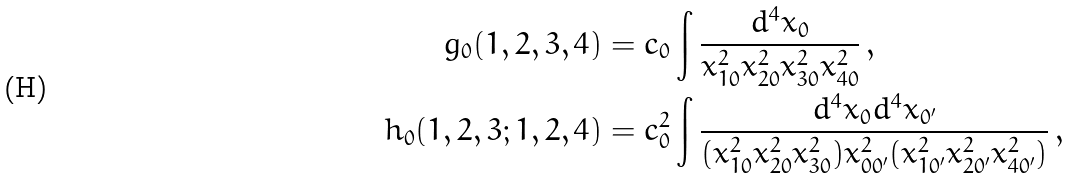<formula> <loc_0><loc_0><loc_500><loc_500>g _ { 0 } ( 1 , 2 , 3 , 4 ) & = c _ { 0 } \int \frac { d ^ { 4 } x _ { 0 } } { x _ { 1 0 } ^ { 2 } x _ { 2 0 } ^ { 2 } x _ { 3 0 } ^ { 2 } x _ { 4 0 } ^ { 2 } } \, , \\ h _ { 0 } ( 1 , 2 , 3 ; 1 , 2 , 4 ) & = c _ { 0 } ^ { 2 } \int \frac { d ^ { 4 } x _ { 0 } d ^ { 4 } x _ { 0 ^ { \prime } } } { ( x _ { 1 0 } ^ { 2 } x _ { 2 0 } ^ { 2 } x _ { 3 0 } ^ { 2 } ) x _ { 0 { 0 ^ { \prime } } } ^ { 2 } ( x _ { 1 { 0 ^ { \prime } } } ^ { 2 } x _ { 2 { 0 ^ { \prime } } } ^ { 2 } x _ { 4 { 0 ^ { \prime } } } ^ { 2 } ) } \, ,</formula> 